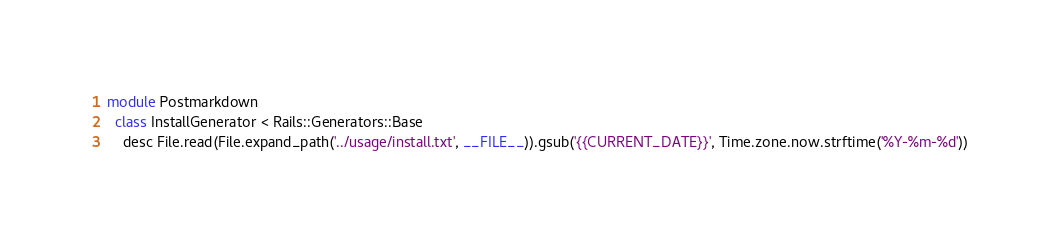<code> <loc_0><loc_0><loc_500><loc_500><_Ruby_>module Postmarkdown
  class InstallGenerator < Rails::Generators::Base
    desc File.read(File.expand_path('../usage/install.txt', __FILE__)).gsub('{{CURRENT_DATE}}', Time.zone.now.strftime('%Y-%m-%d'))</code> 